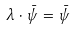<formula> <loc_0><loc_0><loc_500><loc_500>\lambda \cdot \bar { \psi } = \bar { \psi }</formula> 